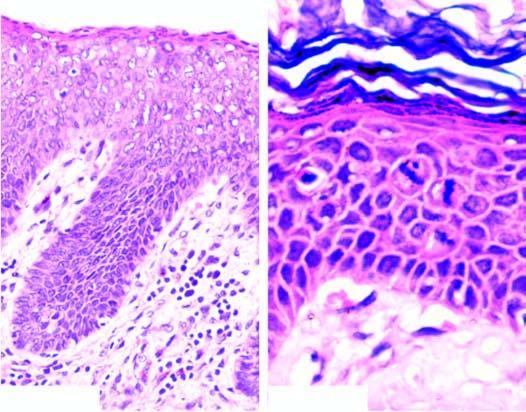what does photomicrograph on right under higher magnification show?
Answer the question using a single word or phrase. Mitotic figures in the layers of squamous epithelium 